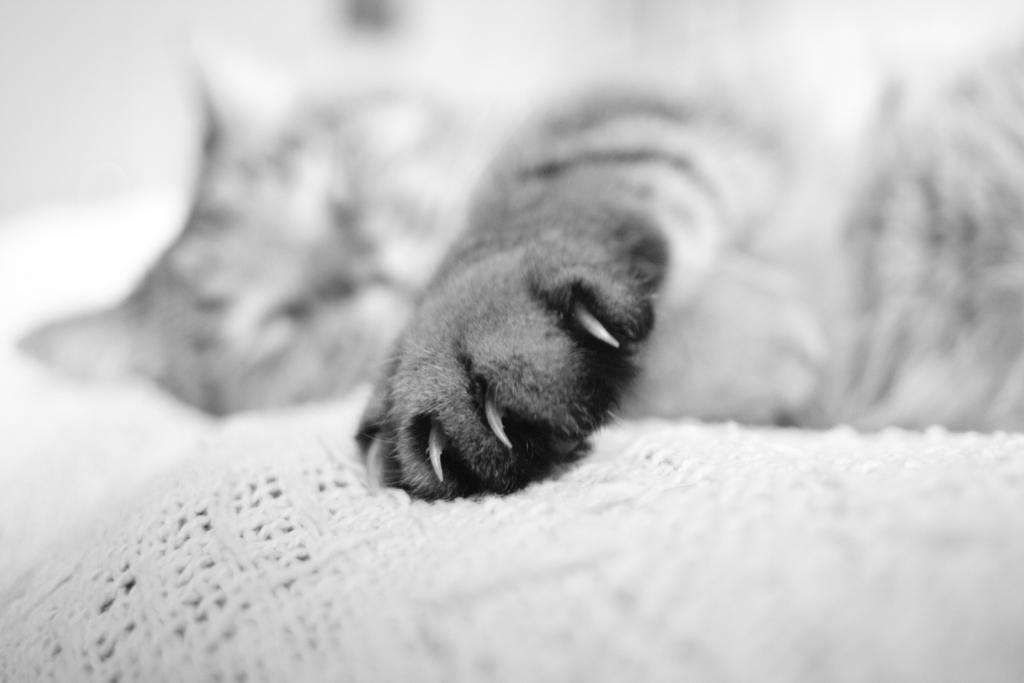What animal is visible in the image? There is a cat lying in the image. What is located at the bottom of the image? There is a cloth at the bottom of the image. How would you describe the background of the image? The background of the image is white and blurred. What type of leather is the cat sitting on in the image? There is no leather present in the image; the cat is lying on a cloth. Can you see a plane flying in the background of the image? There is no plane visible in the image; the background is white and blurred. 